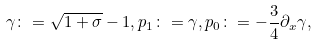Convert formula to latex. <formula><loc_0><loc_0><loc_500><loc_500>\gamma \colon = \sqrt { 1 + \sigma } - 1 , p _ { 1 } \colon = \gamma , p _ { 0 } \colon = - \frac { 3 } { 4 } \partial _ { x } \gamma ,</formula> 